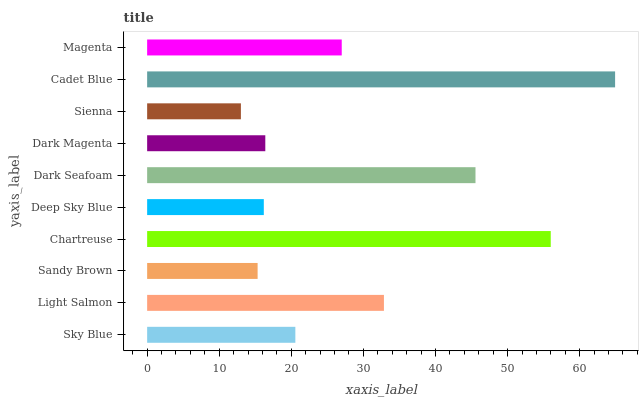Is Sienna the minimum?
Answer yes or no. Yes. Is Cadet Blue the maximum?
Answer yes or no. Yes. Is Light Salmon the minimum?
Answer yes or no. No. Is Light Salmon the maximum?
Answer yes or no. No. Is Light Salmon greater than Sky Blue?
Answer yes or no. Yes. Is Sky Blue less than Light Salmon?
Answer yes or no. Yes. Is Sky Blue greater than Light Salmon?
Answer yes or no. No. Is Light Salmon less than Sky Blue?
Answer yes or no. No. Is Magenta the high median?
Answer yes or no. Yes. Is Sky Blue the low median?
Answer yes or no. Yes. Is Sienna the high median?
Answer yes or no. No. Is Dark Magenta the low median?
Answer yes or no. No. 